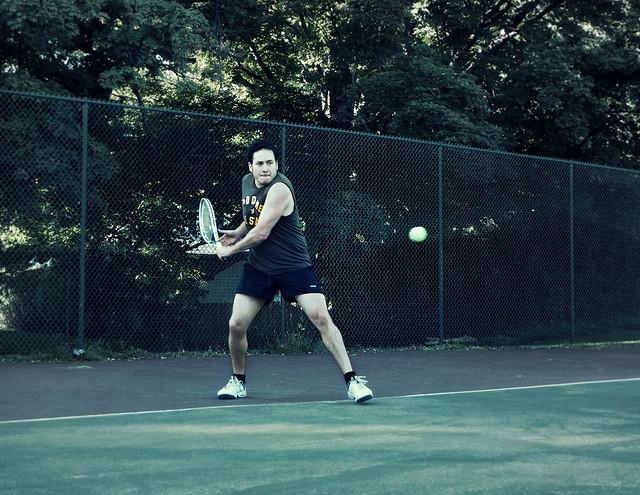What is the people doing?
Answer briefly. Playing tennis. Is the racket in the left hand?
Answer briefly. Yes. Is the man about to hit the ball?
Answer briefly. Yes. Is the man wearing long pants?
Be succinct. No. 